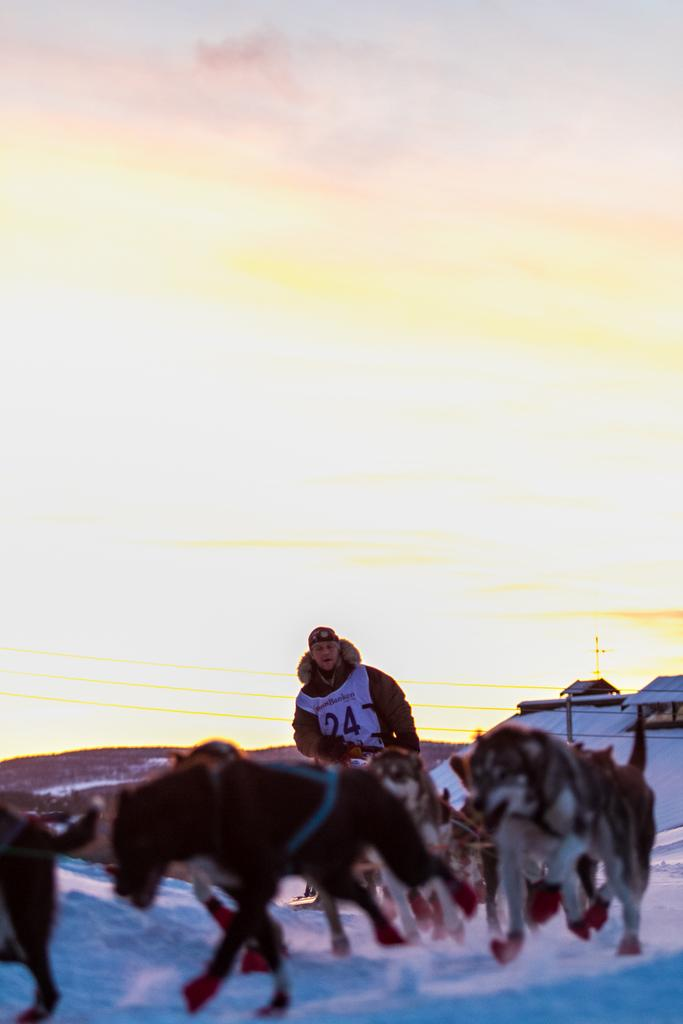What animals are running in the snow in the image? There are wolves running in the snow in the image. Can you describe the person in the image? There is a man in the image. What structure is located on the right side of the image? There is a house on the right side of the image. What can be seen in the sky in the image? There are clouds in the sky in the image. Where are the cherries hanging in the image? There are no cherries present in the image. What type of beast is interacting with the wolves in the image? There is no beast interacting with the wolves in the image; only the wolves, man, house, and clouds are present. 